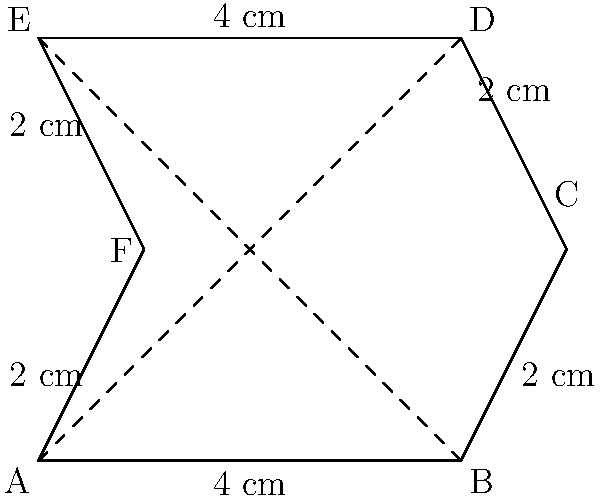A police badge is shaped like an irregular hexagon, as shown in the diagram. Calculate the area of the badge in square centimeters. To calculate the area of this irregular hexagon, we can divide it into simpler shapes:

1. First, divide the hexagon into two trapezoids using the diagonal BE.

2. Calculate the area of the left trapezoid:
   - Base lengths: 4 cm and 4 cm
   - Height: 2 cm
   Area of left trapezoid = $\frac{1}{2}(4 + 4) \times 2 = 8$ cm²

3. Calculate the area of the right trapezoid:
   - Base lengths: 4 cm and 1 cm
   - Height: 2 cm
   Area of right trapezoid = $\frac{1}{2}(4 + 1) \times 2 = 5$ cm²

4. Sum the areas of both trapezoids:
   Total area = $8 + 5 = 13$ cm²

Therefore, the area of the police badge is 13 square centimeters.
Answer: 13 cm² 